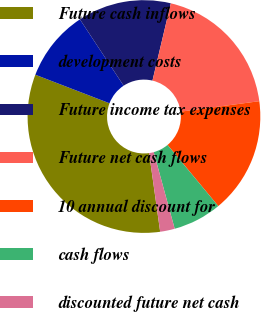<chart> <loc_0><loc_0><loc_500><loc_500><pie_chart><fcel>Future cash inflows<fcel>development costs<fcel>Future income tax expenses<fcel>Future net cash flows<fcel>10 annual discount for<fcel>cash flows<fcel>discounted future net cash<nl><fcel>33.07%<fcel>9.88%<fcel>12.98%<fcel>19.19%<fcel>16.08%<fcel>6.77%<fcel>2.03%<nl></chart> 